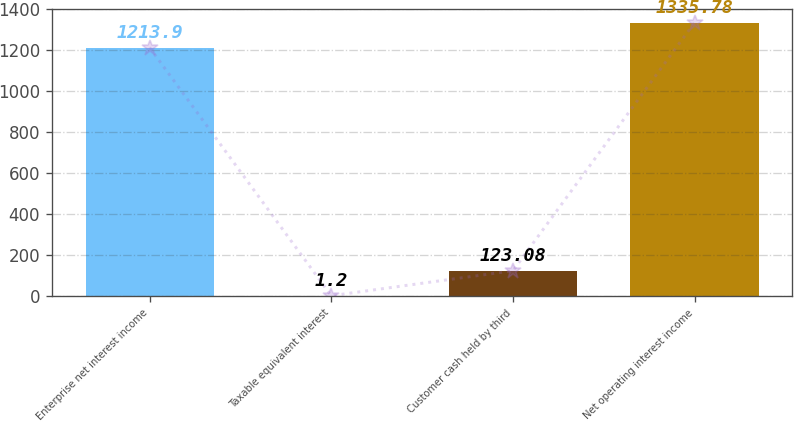<chart> <loc_0><loc_0><loc_500><loc_500><bar_chart><fcel>Enterprise net interest income<fcel>Taxable equivalent interest<fcel>Customer cash held by third<fcel>Net operating interest income<nl><fcel>1213.9<fcel>1.2<fcel>123.08<fcel>1335.78<nl></chart> 